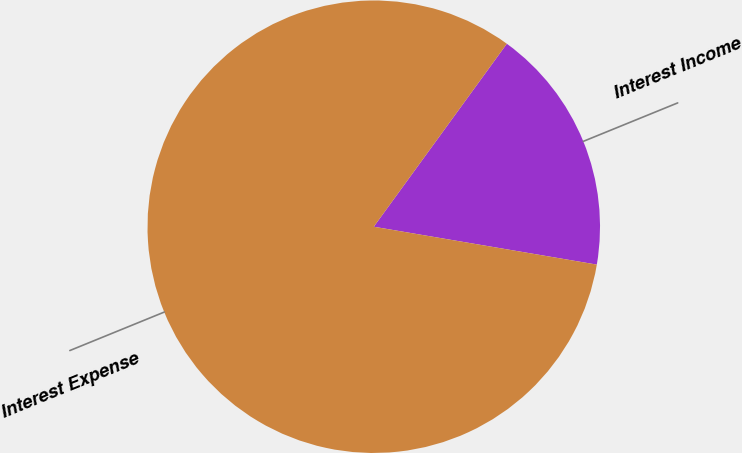Convert chart to OTSL. <chart><loc_0><loc_0><loc_500><loc_500><pie_chart><fcel>Interest Income<fcel>Interest Expense<nl><fcel>17.67%<fcel>82.33%<nl></chart> 